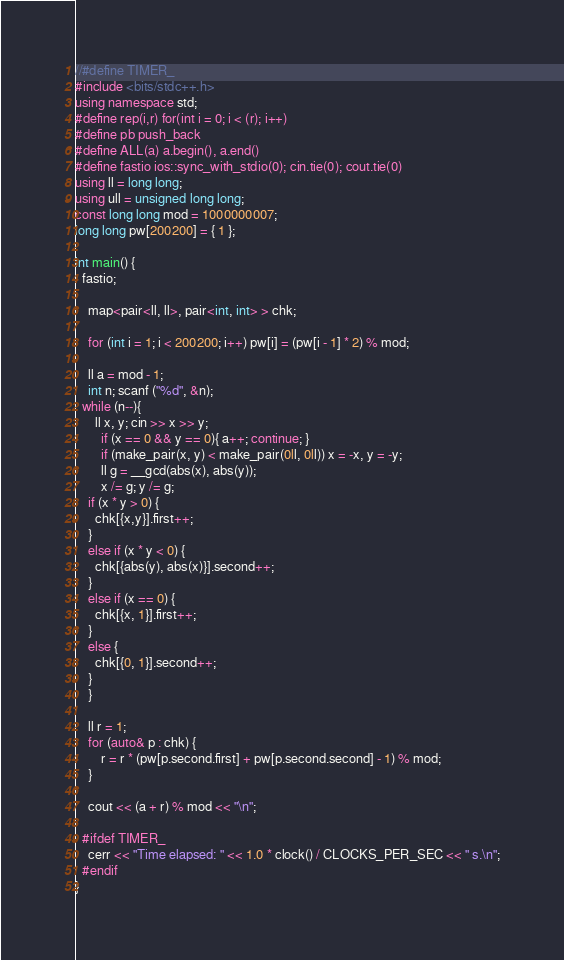Convert code to text. <code><loc_0><loc_0><loc_500><loc_500><_C++_>//#define TIMER_
#include <bits/stdc++.h>
using namespace std;
#define rep(i,r) for(int i = 0; i < (r); i++)
#define pb push_back
#define ALL(a) a.begin(), a.end()
#define fastio ios::sync_with_stdio(0); cin.tie(0); cout.tie(0)
using ll = long long;
using ull = unsigned long long;
const long long mod = 1000000007;
long long pw[200200] = { 1 };

int main() {
  fastio;

	map<pair<ll, ll>, pair<int, int> > chk;

	for (int i = 1; i < 200200; i++) pw[i] = (pw[i - 1] * 2) % mod;

	ll a = mod - 1;
	int n; scanf ("%d", &n); 
  while (n--){
	  ll x, y; cin >> x >> y;
		if (x == 0 && y == 0){ a++; continue; }
		if (make_pair(x, y) < make_pair(0ll, 0ll)) x = -x, y = -y;
		ll g = __gcd(abs(x), abs(y));
		x /= g; y /= g;
    if (x * y > 0) {
      chk[{x,y}].first++;
    } 
    else if (x * y < 0) {
      chk[{abs(y), abs(x)}].second++;
    }
    else if (x == 0) {
      chk[{x, 1}].first++;
    } 
    else {
      chk[{0, 1}].second++;
    }
	}

	ll r = 1;
	for (auto& p : chk) {
		r = r * (pw[p.second.first] + pw[p.second.second] - 1) % mod;
	}

	cout << (a + r) % mod << "\n";
  
  #ifdef TIMER_
    cerr << "Time elapsed: " << 1.0 * clock() / CLOCKS_PER_SEC << " s.\n";
  #endif
}
</code> 